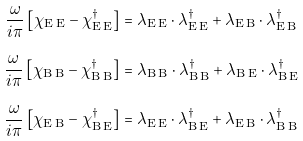<formula> <loc_0><loc_0><loc_500><loc_500>\frac { \omega } { i \pi } \left [ \chi _ { \text {E\,E} } - \chi _ { \text {E\,E} } ^ { \dagger } \right ] & = \lambda _ { \text {E\,E} } \cdot \lambda _ { \text {E\,E} } ^ { \dagger } + \lambda _ { \text {E\,B} } \cdot \lambda _ { \text {E\,B} } ^ { \dagger } \\ \frac { \omega } { i \pi } \left [ \chi _ { \text {B\,B} } - \chi _ { \text {B\,B} } ^ { \dagger } \right ] & = \lambda _ { \text {B\,B} } \cdot \lambda _ { \text {B\,B} } ^ { \dagger } + \lambda _ { \text {B\,E} } \cdot \lambda _ { \text {B\,E} } ^ { \dagger } \\ \frac { \omega } { i \pi } \left [ \chi _ { \text {E\,B} } - \chi _ { \text {B\,E} } ^ { \dagger } \right ] & = \lambda _ { \text {E\,E} } \cdot \lambda _ { \text {B\,E} } ^ { \dagger } + \lambda _ { \text {E\,B} } \cdot \lambda _ { \text {B\,B} } ^ { \dagger } \\</formula> 